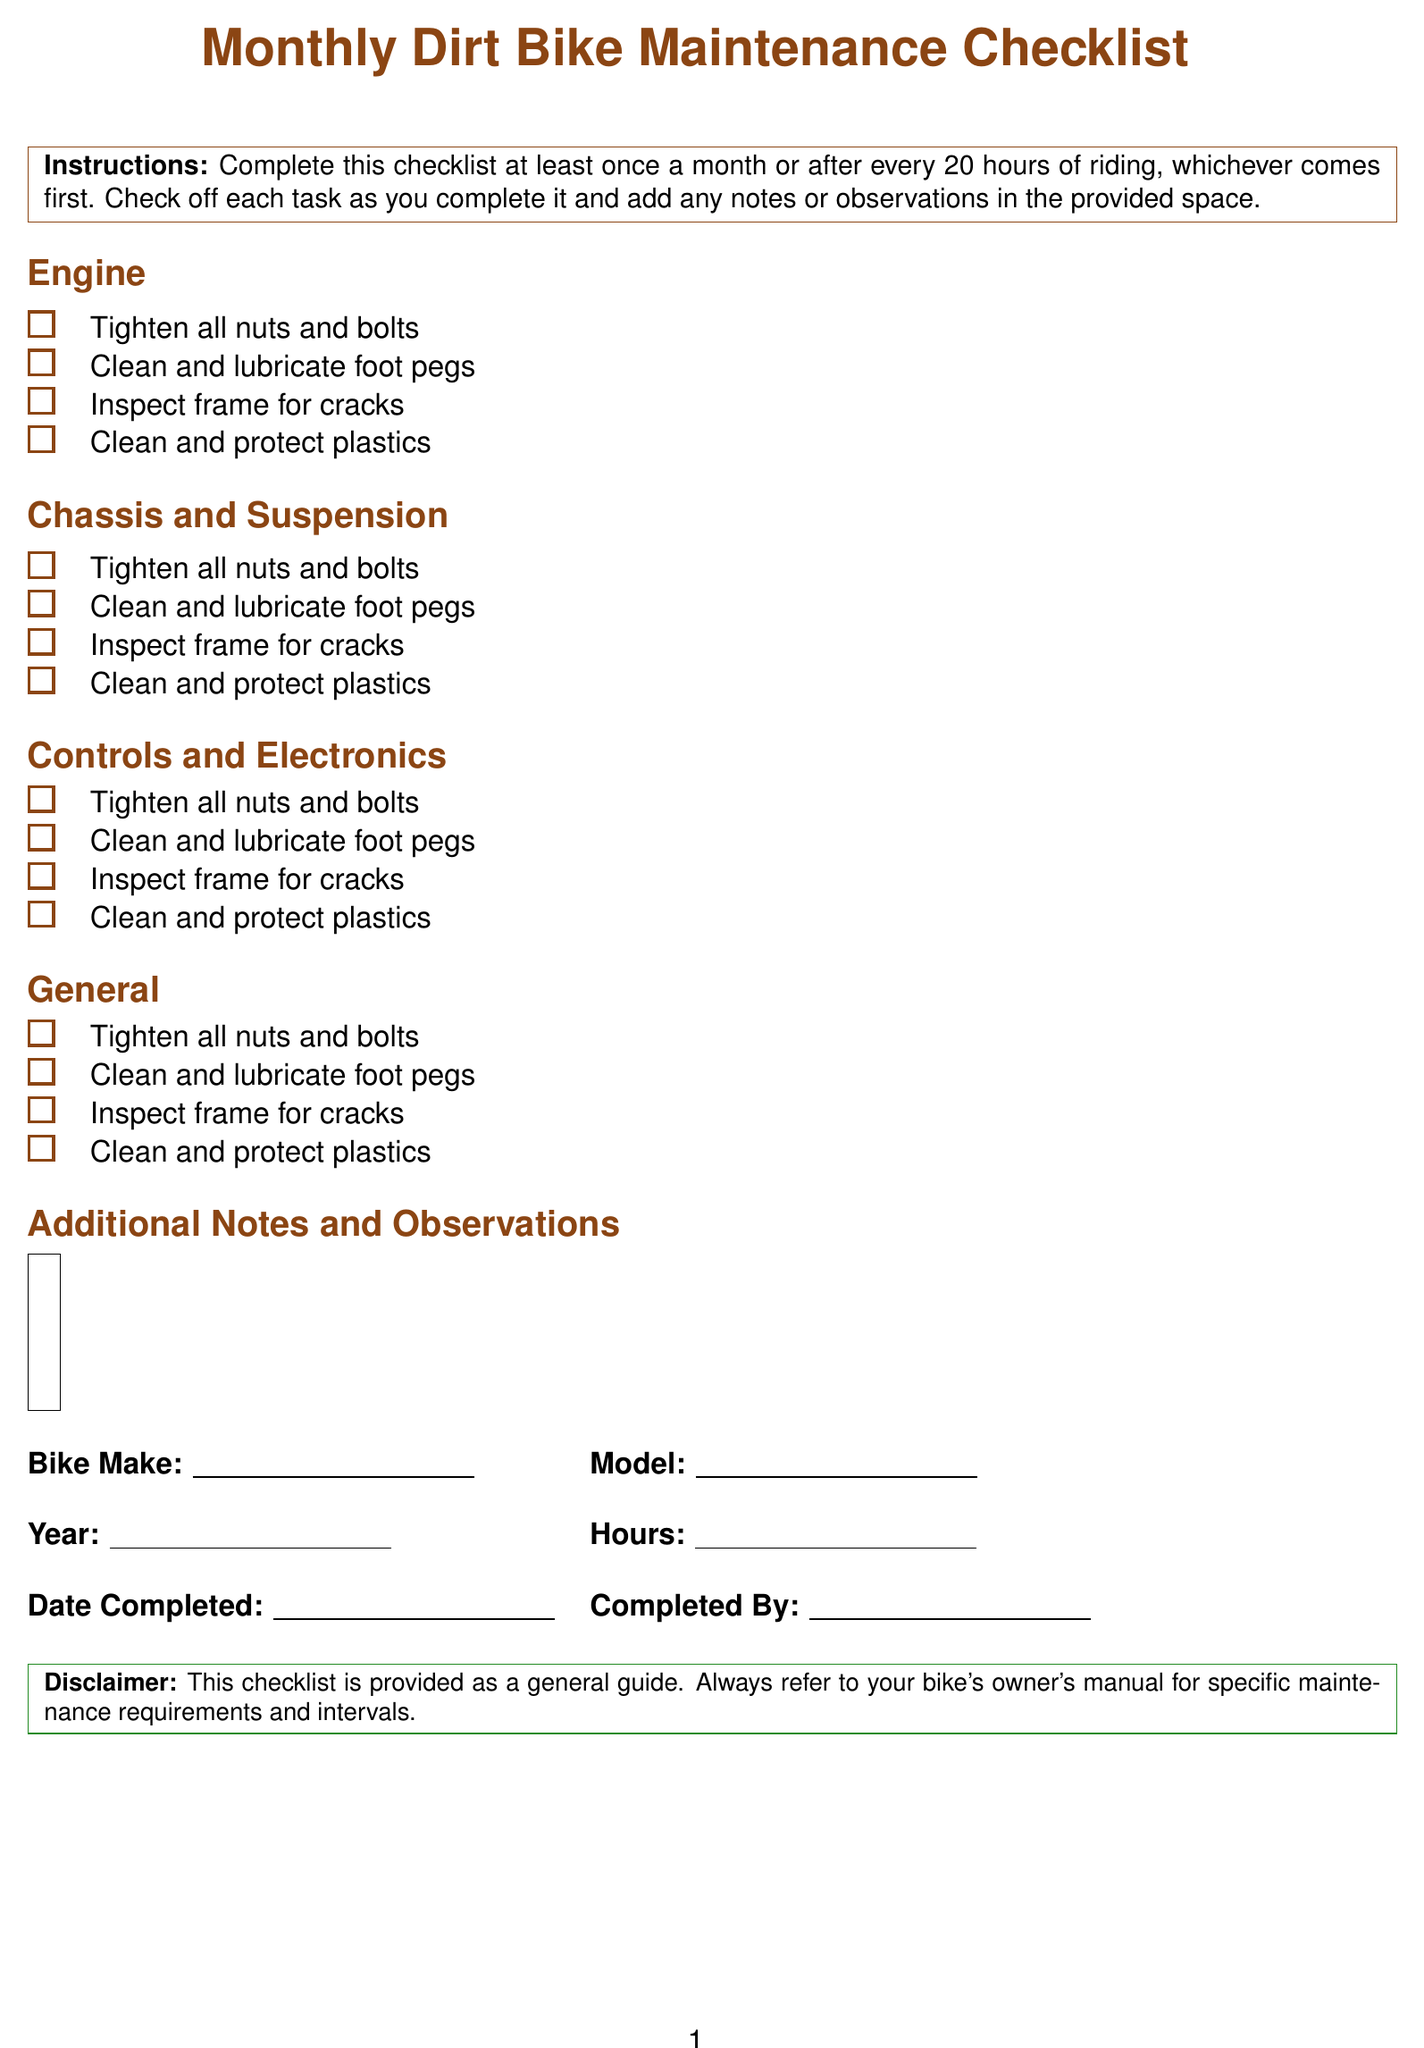What is the title of the form? The title of the form is prominently displayed at the top of the document, indicating its purpose.
Answer: Monthly Dirt Bike Maintenance Checklist How many tasks are listed under "Chassis and Suspension"? The document enumerates tasks in the "Chassis and Suspension" section, allowing for easy counting of the items.
Answer: 6 What is the purpose of the checklist? The instructions provide clarity on when the checklist should be completed and the importance of maintaining the bike.
Answer: Monthly or after every 20 hours of riding What section includes tasks related to brakes? The form is organized into sections, with specific tasks allocated to the relevant categories.
Answer: Controls and Electronics What should you do with the spark plug? The document specifies necessary actions to maintain optimal engine performance through its tasks.
Answer: Clean or replace spark plug Which two components are checked in the "General" section? The tasks are grouped logically within sections, reflecting maintenance priorities.
Answer: Nuts and bolts; foot pegs 